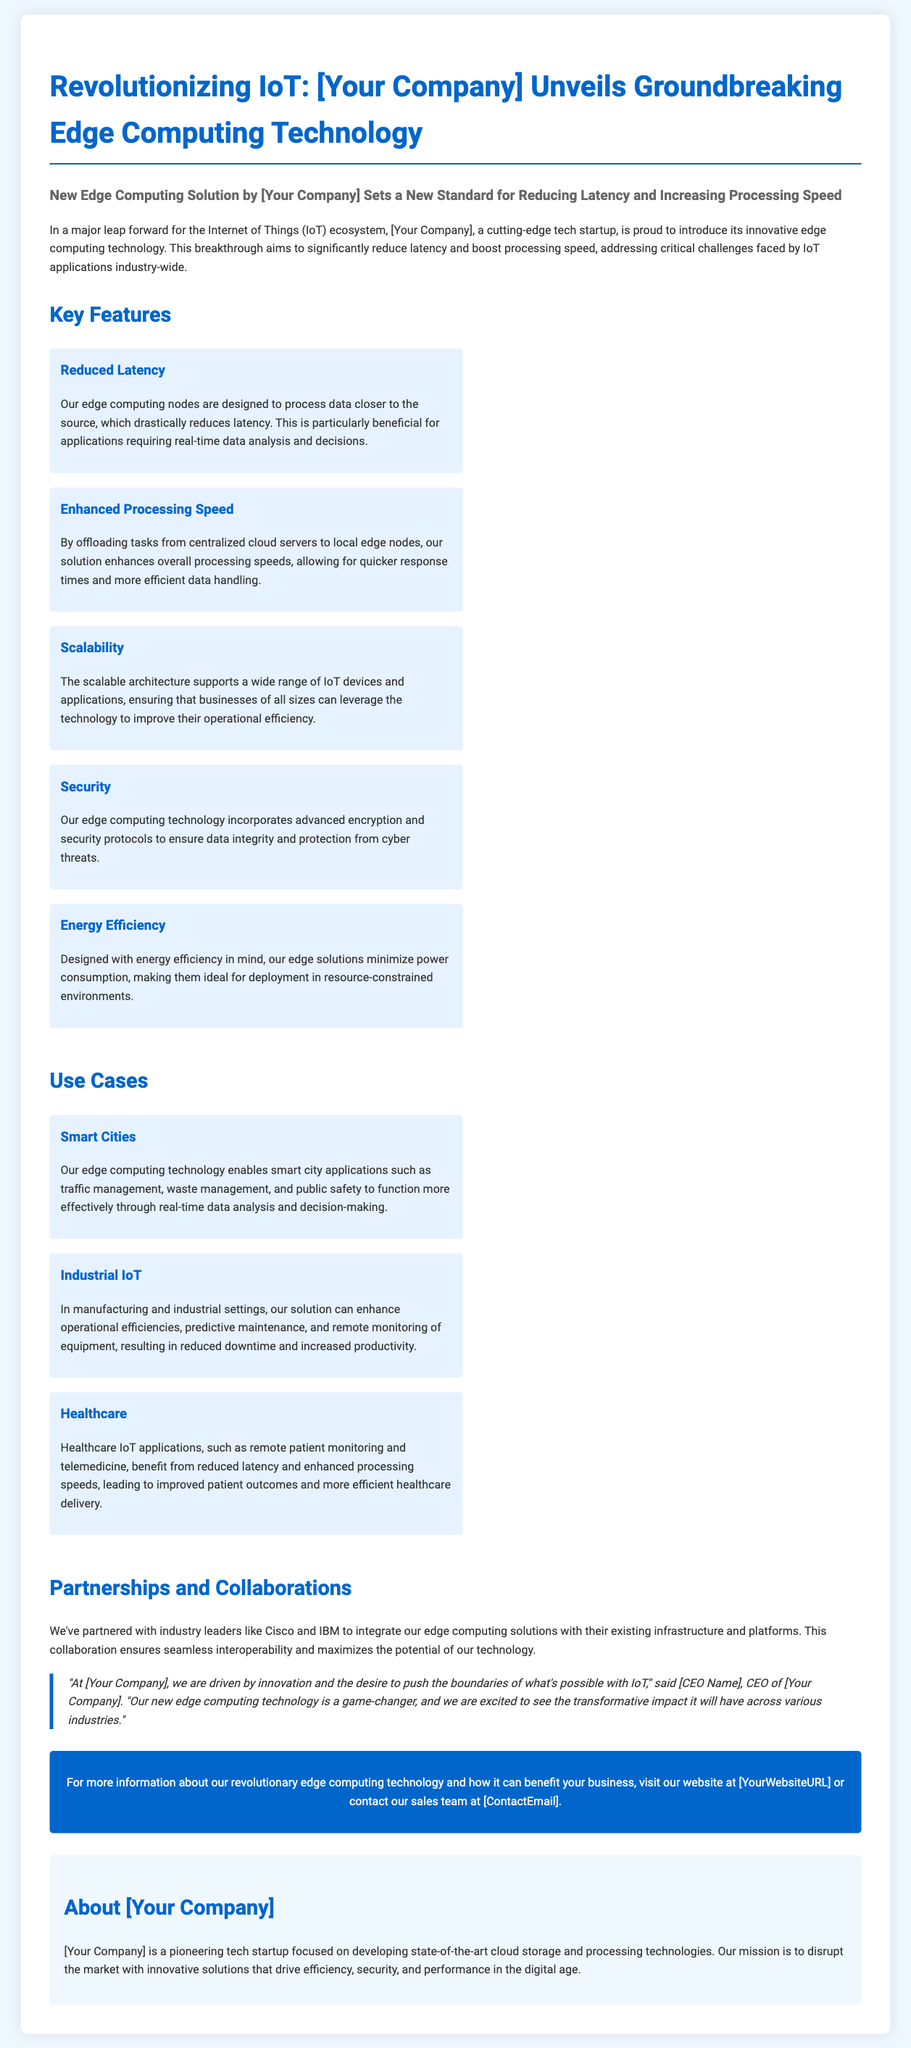What is the title of the press release? The title of the press release is prominently displayed at the top of the document, indicating the main subject.
Answer: Revolutionizing IoT: [Your Company] Unveils Groundbreaking Edge Computing Technology Who is the CEO of [Your Company]? The document includes a quotation from the CEO, which typically mentions their name as part of the executive statement.
Answer: [CEO Name] What is a key benefit of the new edge computing technology? The press release lists multiple key features that are benefits of the technology, highlighting significant advantages.
Answer: Reduced Latency Which companies has [Your Company] partnered with? The document specifically mentions industry collaborations which showcase partnerships for improved integration.
Answer: Cisco and IBM What sector does the edge computing technology improve in healthcare? In the healthcare section, it mentions specific applications that benefit from the new technology's features.
Answer: Remote patient monitoring What type of document is this? The content and format of the document align with a specific type of announcement typically issued by organizations to inform the public.
Answer: Press release How does the technology affect energy usage? The document states a specific design goal that is related to the operational efficiency of the technology.
Answer: Energy Efficiency What is the potential impact of the edge computing technology? The press release contains quotations that reflect the broader implications for various industries of adopting the technology.
Answer: Game-changer 